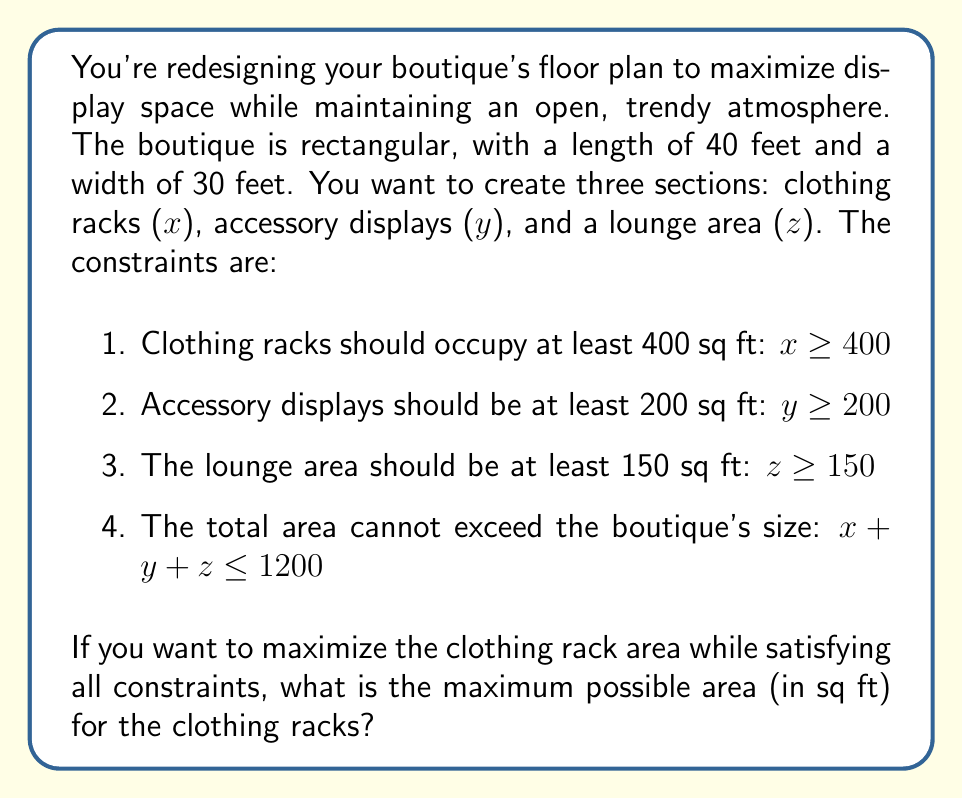Can you solve this math problem? To solve this problem, we'll use a system of inequalities and the concept of linear programming:

1. Set up the system of inequalities:
   $x \geq 400$
   $y \geq 200$
   $z \geq 150$
   $x + y + z \leq 1200$

2. Since we want to maximize x (clothing rack area), we'll set y and z to their minimum values:
   $y = 200$
   $z = 150$

3. Substitute these values into the last inequality:
   $x + 200 + 150 \leq 1200$
   $x + 350 \leq 1200$

4. Solve for x:
   $x \leq 1200 - 350$
   $x \leq 850$

5. Check if this satisfies the first constraint ($x \geq 400$):
   It does, as 850 > 400.

6. Therefore, the maximum possible area for clothing racks is 850 sq ft.

This layout ensures that all constraints are met while maximizing the clothing display area, which is crucial for a fashion boutique.
Answer: 850 sq ft 